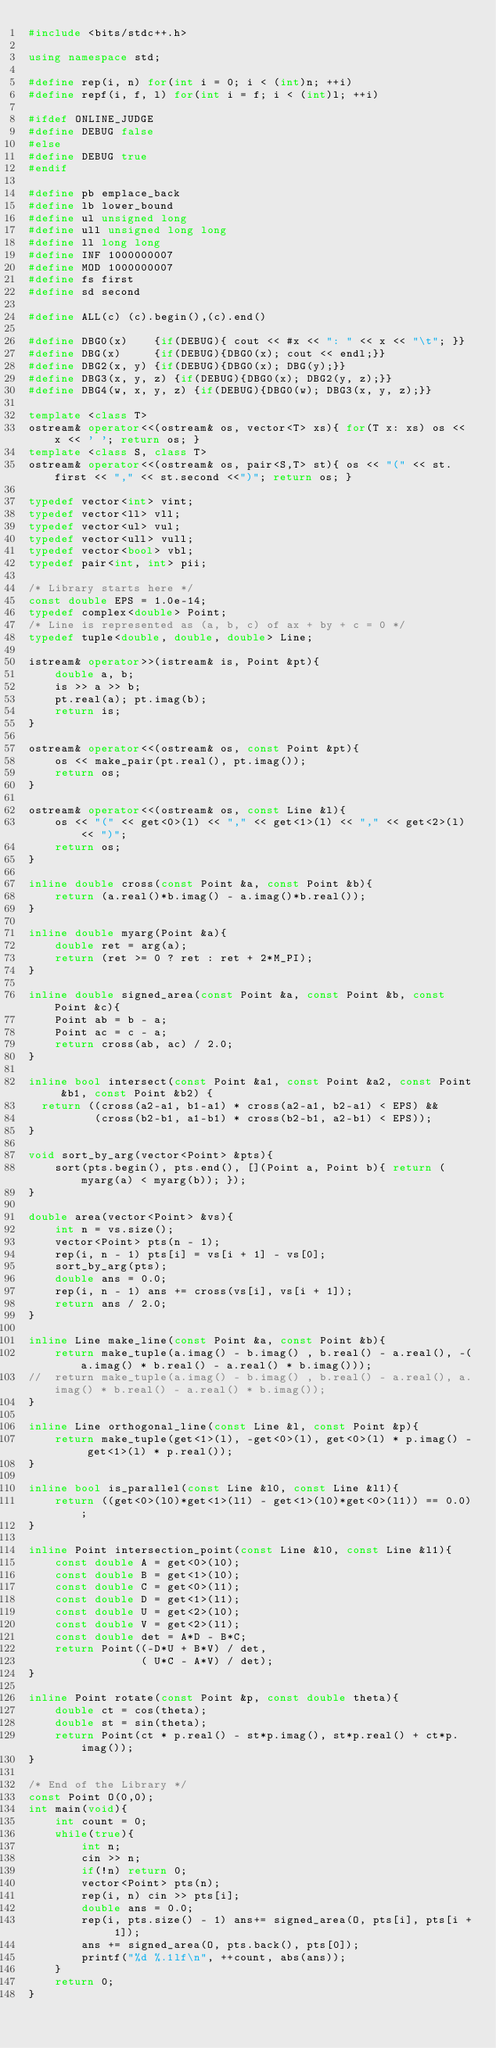Convert code to text. <code><loc_0><loc_0><loc_500><loc_500><_C++_>#include <bits/stdc++.h>

using namespace std;

#define rep(i, n) for(int i = 0; i < (int)n; ++i)
#define repf(i, f, l) for(int i = f; i < (int)l; ++i)

#ifdef ONLINE_JUDGE
#define DEBUG false
#else
#define DEBUG true
#endif

#define pb emplace_back
#define lb lower_bound
#define ul unsigned long
#define ull unsigned long long
#define ll long long
#define INF 1000000007
#define MOD 1000000007
#define fs first
#define sd second

#define ALL(c) (c).begin(),(c).end()

#define DBG0(x)    {if(DEBUG){ cout << #x << ": " << x << "\t"; }}
#define DBG(x)     {if(DEBUG){DBG0(x); cout << endl;}}
#define DBG2(x, y) {if(DEBUG){DBG0(x); DBG(y);}}
#define DBG3(x, y, z) {if(DEBUG){DBG0(x); DBG2(y, z);}}
#define DBG4(w, x, y, z) {if(DEBUG){DBG0(w); DBG3(x, y, z);}}

template <class T>
ostream& operator<<(ostream& os, vector<T> xs){ for(T x: xs) os << x << ' '; return os; }
template <class S, class T>
ostream& operator<<(ostream& os, pair<S,T> st){ os << "(" << st.first << "," << st.second <<")"; return os; }

typedef vector<int> vint;
typedef vector<ll> vll;
typedef vector<ul> vul;
typedef vector<ull> vull;
typedef vector<bool> vbl;
typedef pair<int, int> pii;

/* Library starts here */
const double EPS = 1.0e-14;
typedef complex<double> Point;
/* Line is represented as (a, b, c) of ax + by + c = 0 */
typedef tuple<double, double, double> Line;

istream& operator>>(istream& is, Point &pt){
    double a, b;
    is >> a >> b;
    pt.real(a); pt.imag(b);
    return is;
}

ostream& operator<<(ostream& os, const Point &pt){
    os << make_pair(pt.real(), pt.imag());
    return os;
}

ostream& operator<<(ostream& os, const Line &l){
    os << "(" << get<0>(l) << "," << get<1>(l) << "," << get<2>(l) << ")";
    return os;
}

inline double cross(const Point &a, const Point &b){
    return (a.real()*b.imag() - a.imag()*b.real());
}

inline double myarg(Point &a){
    double ret = arg(a);
    return (ret >= 0 ? ret : ret + 2*M_PI);
}

inline double signed_area(const Point &a, const Point &b, const Point &c){
    Point ab = b - a;
    Point ac = c - a;
    return cross(ab, ac) / 2.0;
}

inline bool intersect(const Point &a1, const Point &a2, const Point &b1, const Point &b2) {
  return ((cross(a2-a1, b1-a1) * cross(a2-a1, b2-a1) < EPS) &&
          (cross(b2-b1, a1-b1) * cross(b2-b1, a2-b1) < EPS));
}

void sort_by_arg(vector<Point> &pts){
    sort(pts.begin(), pts.end(), [](Point a, Point b){ return (myarg(a) < myarg(b)); });
}

double area(vector<Point> &vs){
    int n = vs.size();
    vector<Point> pts(n - 1);
    rep(i, n - 1) pts[i] = vs[i + 1] - vs[0];
    sort_by_arg(pts);
    double ans = 0.0;
    rep(i, n - 1) ans += cross(vs[i], vs[i + 1]);
    return ans / 2.0;
}

inline Line make_line(const Point &a, const Point &b){
    return make_tuple(a.imag() - b.imag() , b.real() - a.real(), -(a.imag() * b.real() - a.real() * b.imag()));
//  return make_tuple(a.imag() - b.imag() , b.real() - a.real(), a.imag() * b.real() - a.real() * b.imag());
}

inline Line orthogonal_line(const Line &l, const Point &p){
    return make_tuple(get<1>(l), -get<0>(l), get<0>(l) * p.imag() - get<1>(l) * p.real());
}

inline bool is_parallel(const Line &l0, const Line &l1){
    return ((get<0>(l0)*get<1>(l1) - get<1>(l0)*get<0>(l1)) == 0.0);
}

inline Point intersection_point(const Line &l0, const Line &l1){
    const double A = get<0>(l0);
    const double B = get<1>(l0);
    const double C = get<0>(l1);
    const double D = get<1>(l1);
    const double U = get<2>(l0);
    const double V = get<2>(l1);
    const double det = A*D - B*C;
    return Point((-D*U + B*V) / det,
                 ( U*C - A*V) / det);
}

inline Point rotate(const Point &p, const double theta){
    double ct = cos(theta);
    double st = sin(theta);
    return Point(ct * p.real() - st*p.imag(), st*p.real() + ct*p.imag());
}

/* End of the Library */
const Point O(0,0);
int main(void){
    int count = 0;
    while(true){
        int n;
        cin >> n;
        if(!n) return 0;
        vector<Point> pts(n);
        rep(i, n) cin >> pts[i];
        double ans = 0.0;
        rep(i, pts.size() - 1) ans+= signed_area(O, pts[i], pts[i + 1]);
        ans += signed_area(O, pts.back(), pts[0]);
        printf("%d %.1lf\n", ++count, abs(ans));
    }
    return 0;
}</code> 